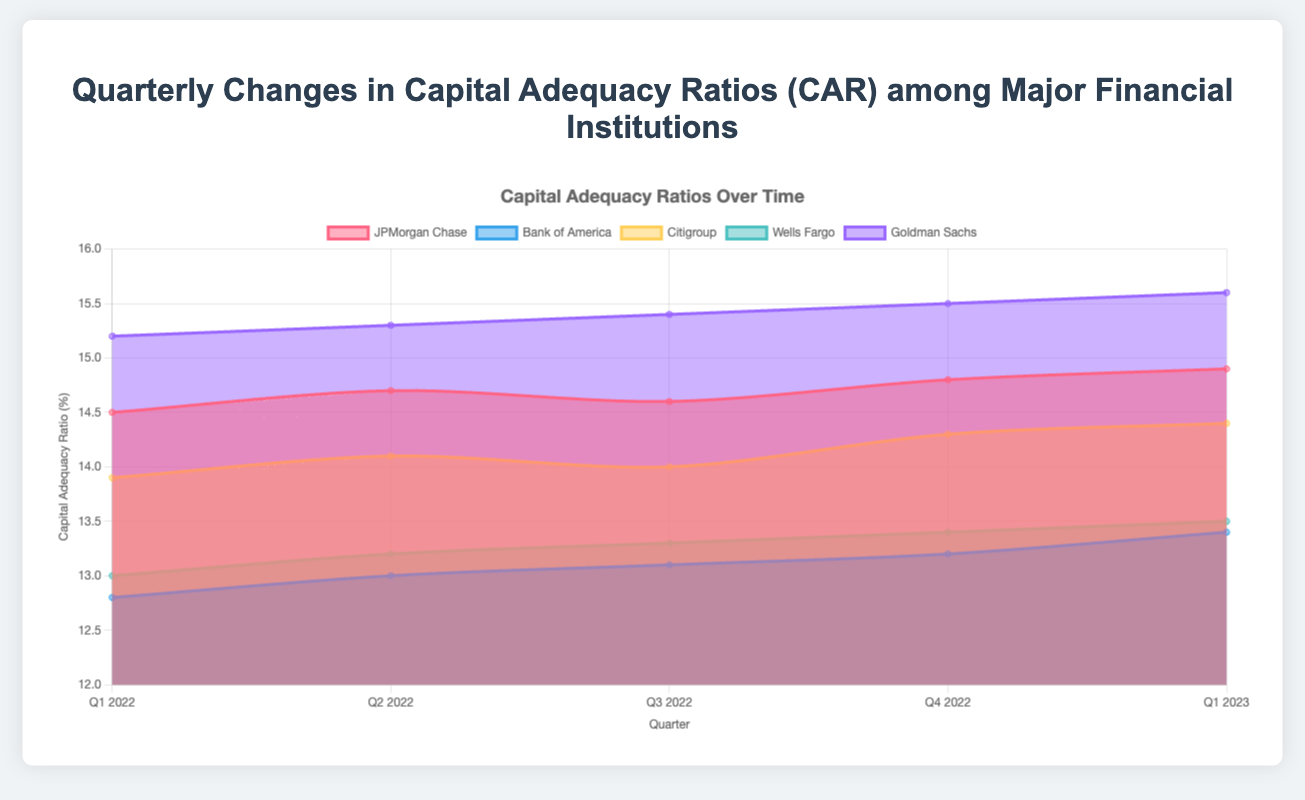What is the title of the chart? The title is typically at the top center of the chart and summarizes its content. Here, the title indicates the focus on CAR changes over time among major financial institutions.
Answer: Quarterly Changes in Capital Adequacy Ratios (CAR) among Major Financial Institutions How many quarters are covered in the chart? The x-axis labels represent the quarters covered. There are points from Q1 2022 to Q1 2023, so five quarters are included.
Answer: 5 Which financial institution had the highest CAR in Q1 2023? Look at the data for Q1 2023 and compare the CAR values. Goldman Sachs has the highest value at this point.
Answer: Goldman Sachs What was the CAR for Citigroup in Q4 2022? Refer to the Citigroup line and find its value at the Q4 2022 point. Citigroup's CAR is 14.3 for Q4 2022.
Answer: 14.3 Which financial institution experienced the most significant increase in CAR from Q2 2022 to Q3 2022? Calculate the change between Q2 2022 and Q3 2022 for each institution, then find the largest increase. Bank of America's CAR increased from 13.0 to 13.1, a 0.1 increase. Other institutions had smaller or negative changes.
Answer: Bank of America Did Wells Fargo's CAR increase or decrease from Q3 2022 to Q4 2022? Look at Wells Fargo's CAR values for Q3 2022 and Q4 2022. It increased from 13.3 to 13.4.
Answer: Increase Which institution showed consistent quarterly increases in CAR? Examine the CAR values for each institution across all quarters. Wells Fargo shows consistent increase in every quarter from 13.0 to 13.5.
Answer: Wells Fargo What was the average CAR for JPMorgan Chase over the five quarters? JPMorgan Chase's CAR values over the quarters are [14.5, 14.7, 14.6, 14.8, 14.9]. Sum these values and divide by 5. (14.5 + 14.7 + 14.6 + 14.8 + 14.9) / 5 = 14.7.
Answer: 14.7 Compare the CAR trend of Goldman Sachs to Bank of America. Which one showed a greater increase from Q1 2022 to Q1 2023? Calculate the change for both institutions from Q1 2022 to Q1 2023. Goldman Sachs increased from 15.2 to 15.6 (0.4) and Bank of America increased from 12.8 to 13.4 (0.6). Bank of America's increase is greater.
Answer: Bank of America What is the overall trend of CAR values for Citigroup over the five quarters? Look at the CAR values for Citigroup across all quarters: [13.9, 14.1, 14.0, 14.3, 14.4]. The overall trend shows a slight increase.
Answer: Increasing 